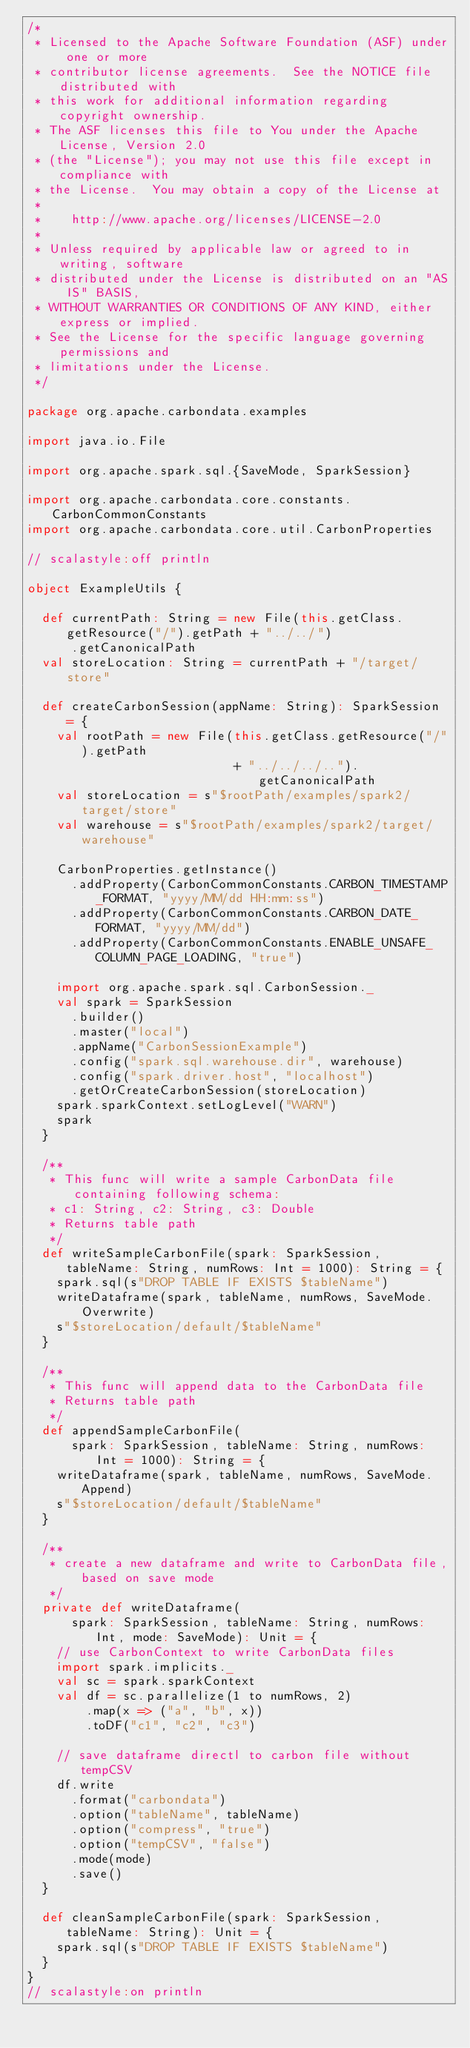<code> <loc_0><loc_0><loc_500><loc_500><_Scala_>/*
 * Licensed to the Apache Software Foundation (ASF) under one or more
 * contributor license agreements.  See the NOTICE file distributed with
 * this work for additional information regarding copyright ownership.
 * The ASF licenses this file to You under the Apache License, Version 2.0
 * (the "License"); you may not use this file except in compliance with
 * the License.  You may obtain a copy of the License at
 *
 *    http://www.apache.org/licenses/LICENSE-2.0
 *
 * Unless required by applicable law or agreed to in writing, software
 * distributed under the License is distributed on an "AS IS" BASIS,
 * WITHOUT WARRANTIES OR CONDITIONS OF ANY KIND, either express or implied.
 * See the License for the specific language governing permissions and
 * limitations under the License.
 */

package org.apache.carbondata.examples

import java.io.File

import org.apache.spark.sql.{SaveMode, SparkSession}

import org.apache.carbondata.core.constants.CarbonCommonConstants
import org.apache.carbondata.core.util.CarbonProperties

// scalastyle:off println

object ExampleUtils {

  def currentPath: String = new File(this.getClass.getResource("/").getPath + "../../")
      .getCanonicalPath
  val storeLocation: String = currentPath + "/target/store"

  def createCarbonSession(appName: String): SparkSession = {
    val rootPath = new File(this.getClass.getResource("/").getPath
                            + "../../../..").getCanonicalPath
    val storeLocation = s"$rootPath/examples/spark2/target/store"
    val warehouse = s"$rootPath/examples/spark2/target/warehouse"

    CarbonProperties.getInstance()
      .addProperty(CarbonCommonConstants.CARBON_TIMESTAMP_FORMAT, "yyyy/MM/dd HH:mm:ss")
      .addProperty(CarbonCommonConstants.CARBON_DATE_FORMAT, "yyyy/MM/dd")
      .addProperty(CarbonCommonConstants.ENABLE_UNSAFE_COLUMN_PAGE_LOADING, "true")

    import org.apache.spark.sql.CarbonSession._
    val spark = SparkSession
      .builder()
      .master("local")
      .appName("CarbonSessionExample")
      .config("spark.sql.warehouse.dir", warehouse)
      .config("spark.driver.host", "localhost")
      .getOrCreateCarbonSession(storeLocation)
    spark.sparkContext.setLogLevel("WARN")
    spark
  }

  /**
   * This func will write a sample CarbonData file containing following schema:
   * c1: String, c2: String, c3: Double
   * Returns table path
   */
  def writeSampleCarbonFile(spark: SparkSession, tableName: String, numRows: Int = 1000): String = {
    spark.sql(s"DROP TABLE IF EXISTS $tableName")
    writeDataframe(spark, tableName, numRows, SaveMode.Overwrite)
    s"$storeLocation/default/$tableName"
  }

  /**
   * This func will append data to the CarbonData file
   * Returns table path
   */
  def appendSampleCarbonFile(
      spark: SparkSession, tableName: String, numRows: Int = 1000): String = {
    writeDataframe(spark, tableName, numRows, SaveMode.Append)
    s"$storeLocation/default/$tableName"
  }

  /**
   * create a new dataframe and write to CarbonData file, based on save mode
   */
  private def writeDataframe(
      spark: SparkSession, tableName: String, numRows: Int, mode: SaveMode): Unit = {
    // use CarbonContext to write CarbonData files
    import spark.implicits._
    val sc = spark.sparkContext
    val df = sc.parallelize(1 to numRows, 2)
        .map(x => ("a", "b", x))
        .toDF("c1", "c2", "c3")

    // save dataframe directl to carbon file without tempCSV
    df.write
      .format("carbondata")
      .option("tableName", tableName)
      .option("compress", "true")
      .option("tempCSV", "false")
      .mode(mode)
      .save()
  }

  def cleanSampleCarbonFile(spark: SparkSession, tableName: String): Unit = {
    spark.sql(s"DROP TABLE IF EXISTS $tableName")
  }
}
// scalastyle:on println

</code> 